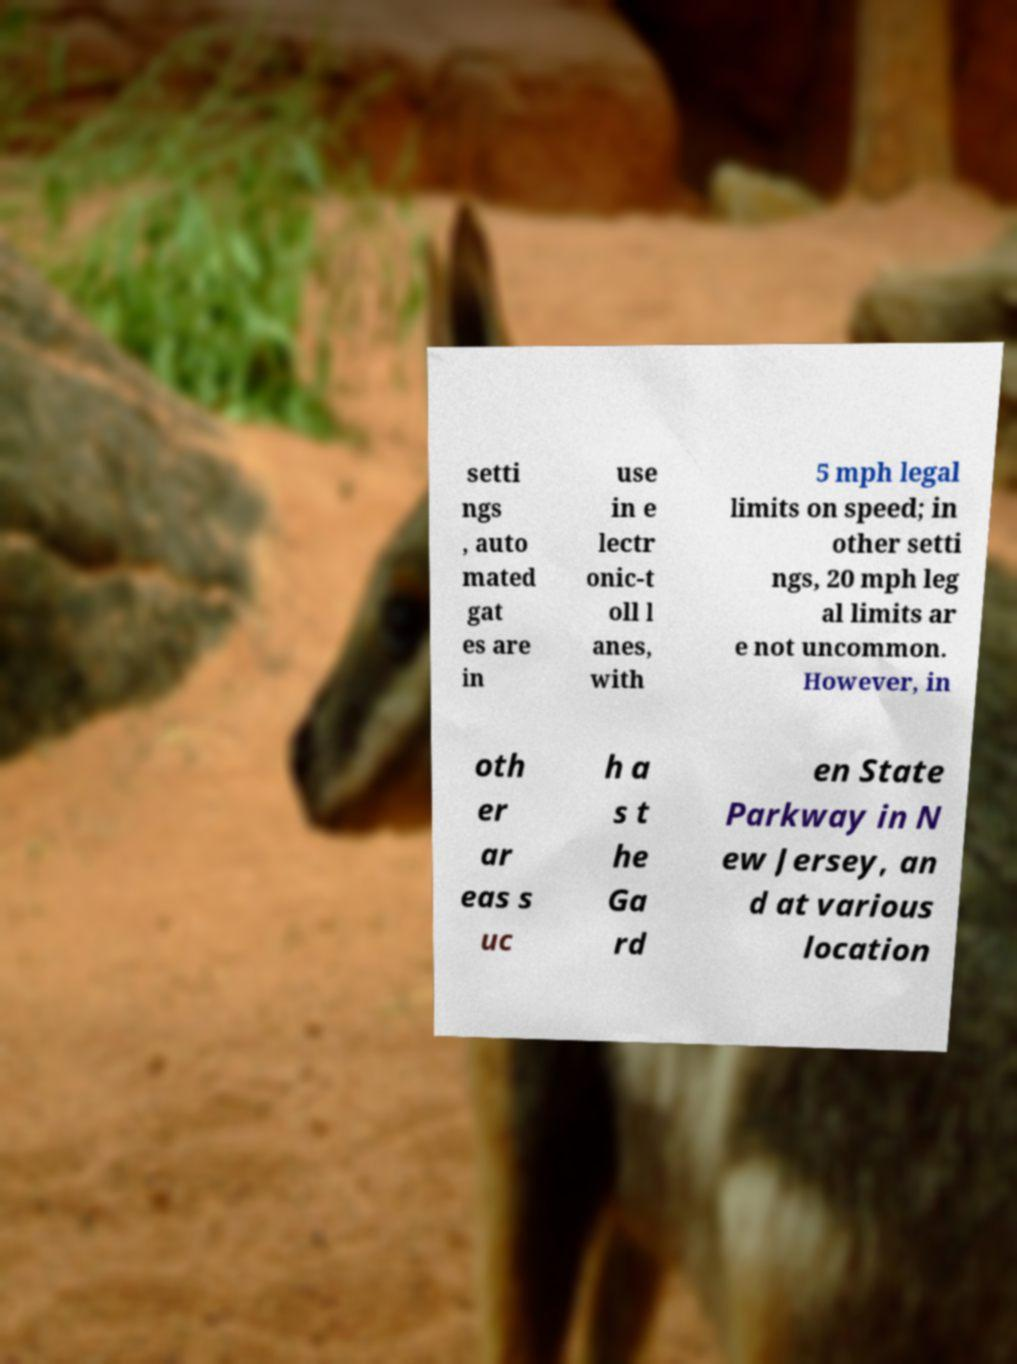Can you read and provide the text displayed in the image?This photo seems to have some interesting text. Can you extract and type it out for me? setti ngs , auto mated gat es are in use in e lectr onic-t oll l anes, with 5 mph legal limits on speed; in other setti ngs, 20 mph leg al limits ar e not uncommon. However, in oth er ar eas s uc h a s t he Ga rd en State Parkway in N ew Jersey, an d at various location 